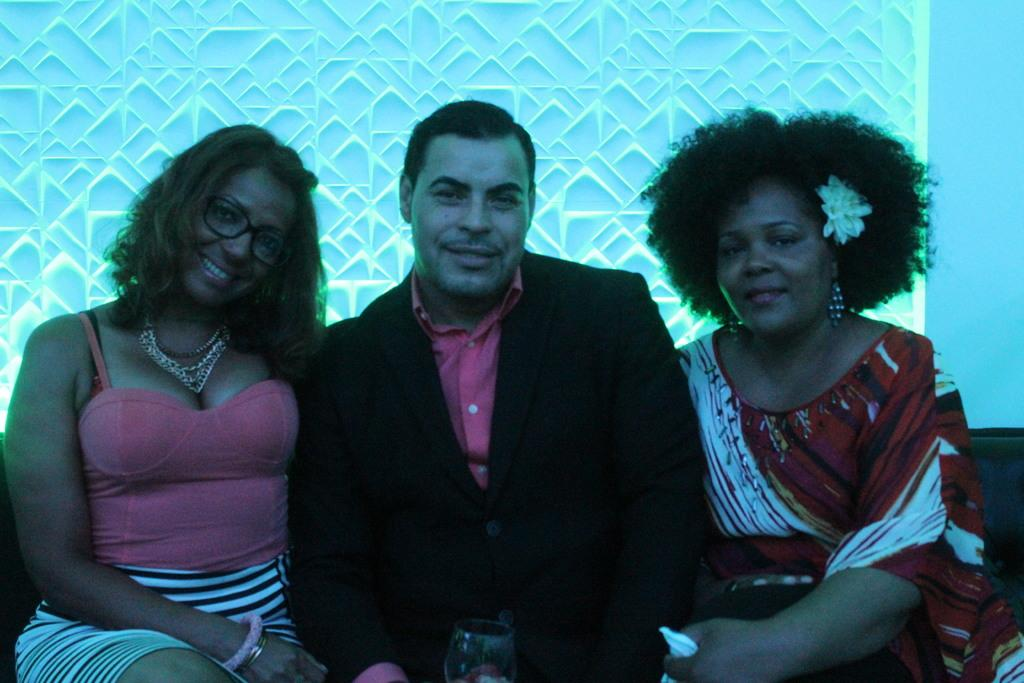How many people are in the image? There are three persons in the image. What are the persons doing in the image? The persons are sitting. What expression do the persons have in the image? The persons are smiling. What can be seen in the background of the image? There is a wall in the background of the image. Is there a beggar asking for money in the image? There is no beggar present in the image. Can you see a toad hopping on the wall in the background? There is no toad visible in the image; only the persons and the wall are present. 